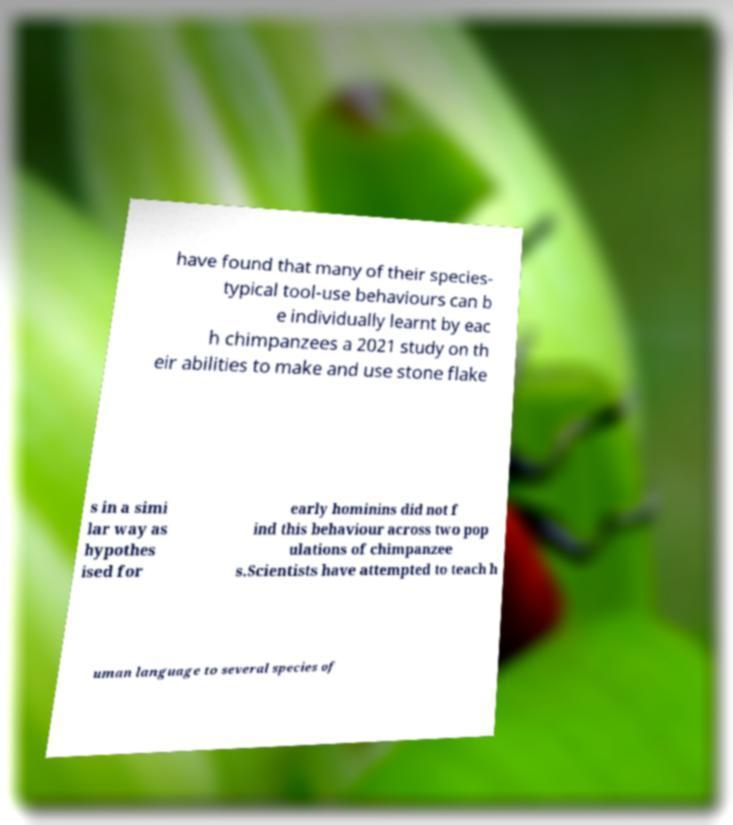Can you accurately transcribe the text from the provided image for me? have found that many of their species- typical tool-use behaviours can b e individually learnt by eac h chimpanzees a 2021 study on th eir abilities to make and use stone flake s in a simi lar way as hypothes ised for early hominins did not f ind this behaviour across two pop ulations of chimpanzee s.Scientists have attempted to teach h uman language to several species of 